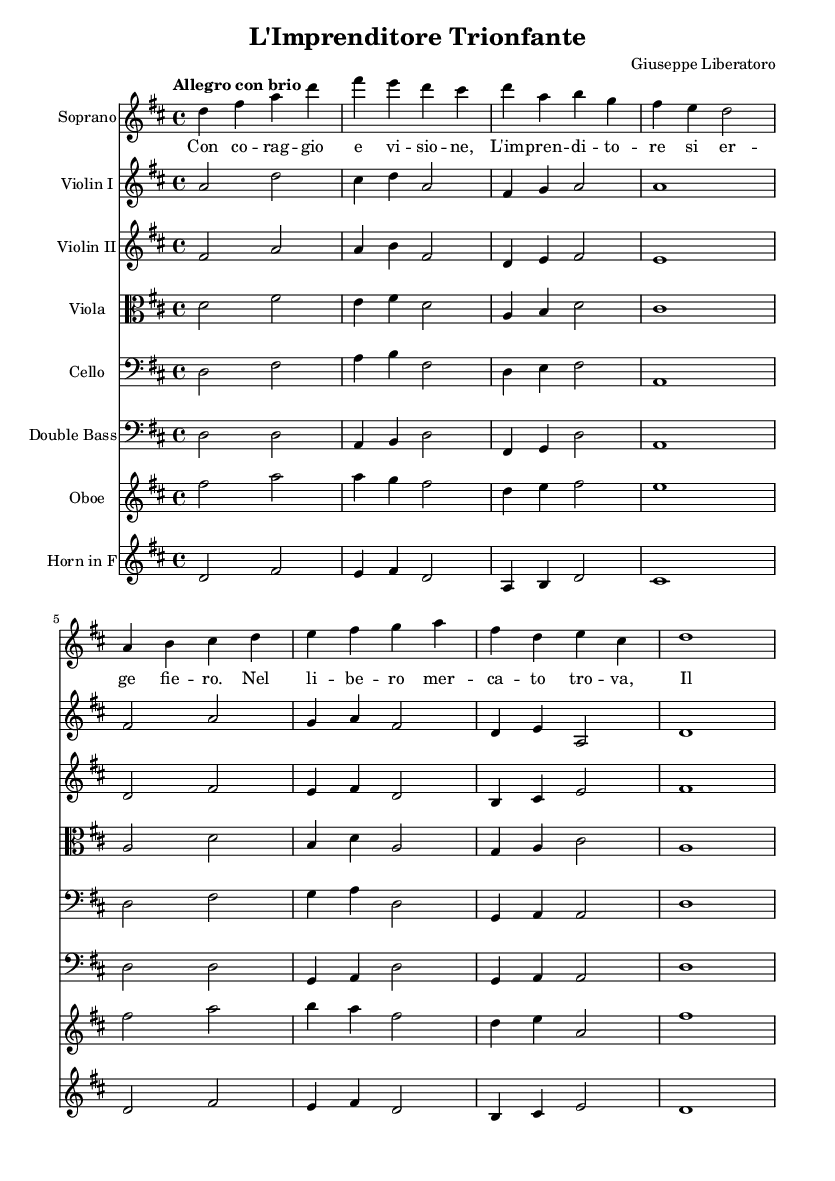What is the key signature of this music? The key signature indicates the key in which the piece is written. In this sheet music, it shows two sharps, which corresponds to the key of D major.
Answer: D major What is the time signature of this music? The time signature is specified at the beginning of the piece, indicated as 4/4, which means there are four beats in each measure and a quarter note gets one beat.
Answer: 4/4 What is the tempo marking for this piece? The tempo marking is described at the start of the music as "Allegro con brio", a common musical term indicating a fast, lively tempo.
Answer: Allegro con brio Who is the composer of this opera? The composer is mentioned in the header of the sheet music as "Giuseppe Liberatoro".
Answer: Giuseppe Liberatoro What themes are celebrated in this opera? The lyrics suggest that the opera celebrates themes of individual achievement and entrepreneurship, reflecting the success of a thriving entrepreneur.
Answer: Individual achievement and entrepreneurship Which instrument has the melody in the opening? The opening melody is primarily carried by the Soprano voice, which sings the initial melodic line.
Answer: Soprano How many different instruments are represented in this score? By counting the different staves present, we can identify that there are eight different instruments represented in the score.
Answer: Eight 